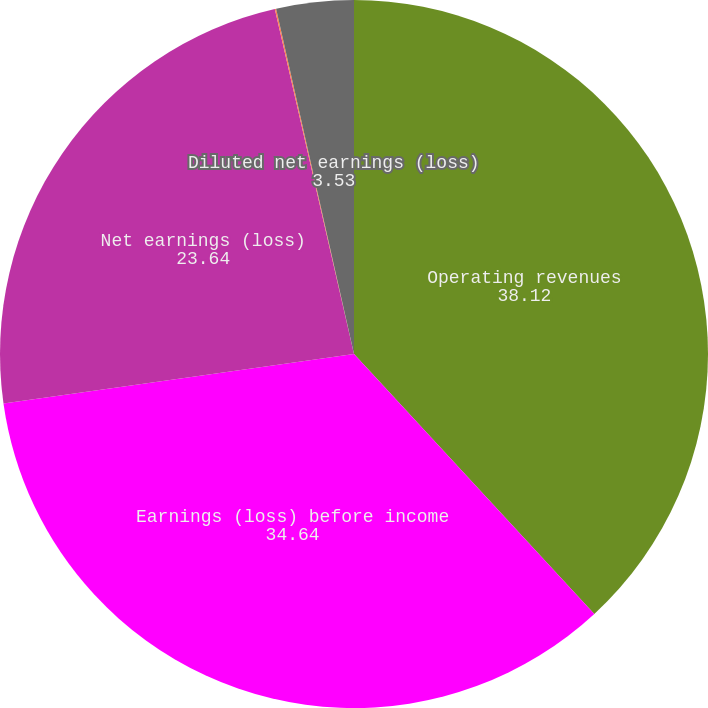<chart> <loc_0><loc_0><loc_500><loc_500><pie_chart><fcel>Operating revenues<fcel>Earnings (loss) before income<fcel>Net earnings (loss)<fcel>Basic net earnings (loss) per<fcel>Diluted net earnings (loss)<nl><fcel>38.12%<fcel>34.64%<fcel>23.64%<fcel>0.06%<fcel>3.53%<nl></chart> 